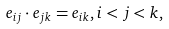<formula> <loc_0><loc_0><loc_500><loc_500>e _ { i j } \cdot e _ { j k } = e _ { i k } , i < j < k ,</formula> 